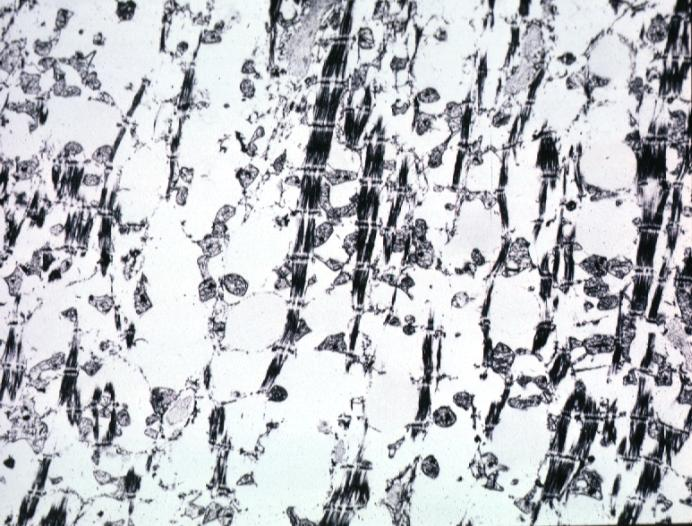s chronic ischemia present?
Answer the question using a single word or phrase. Yes 